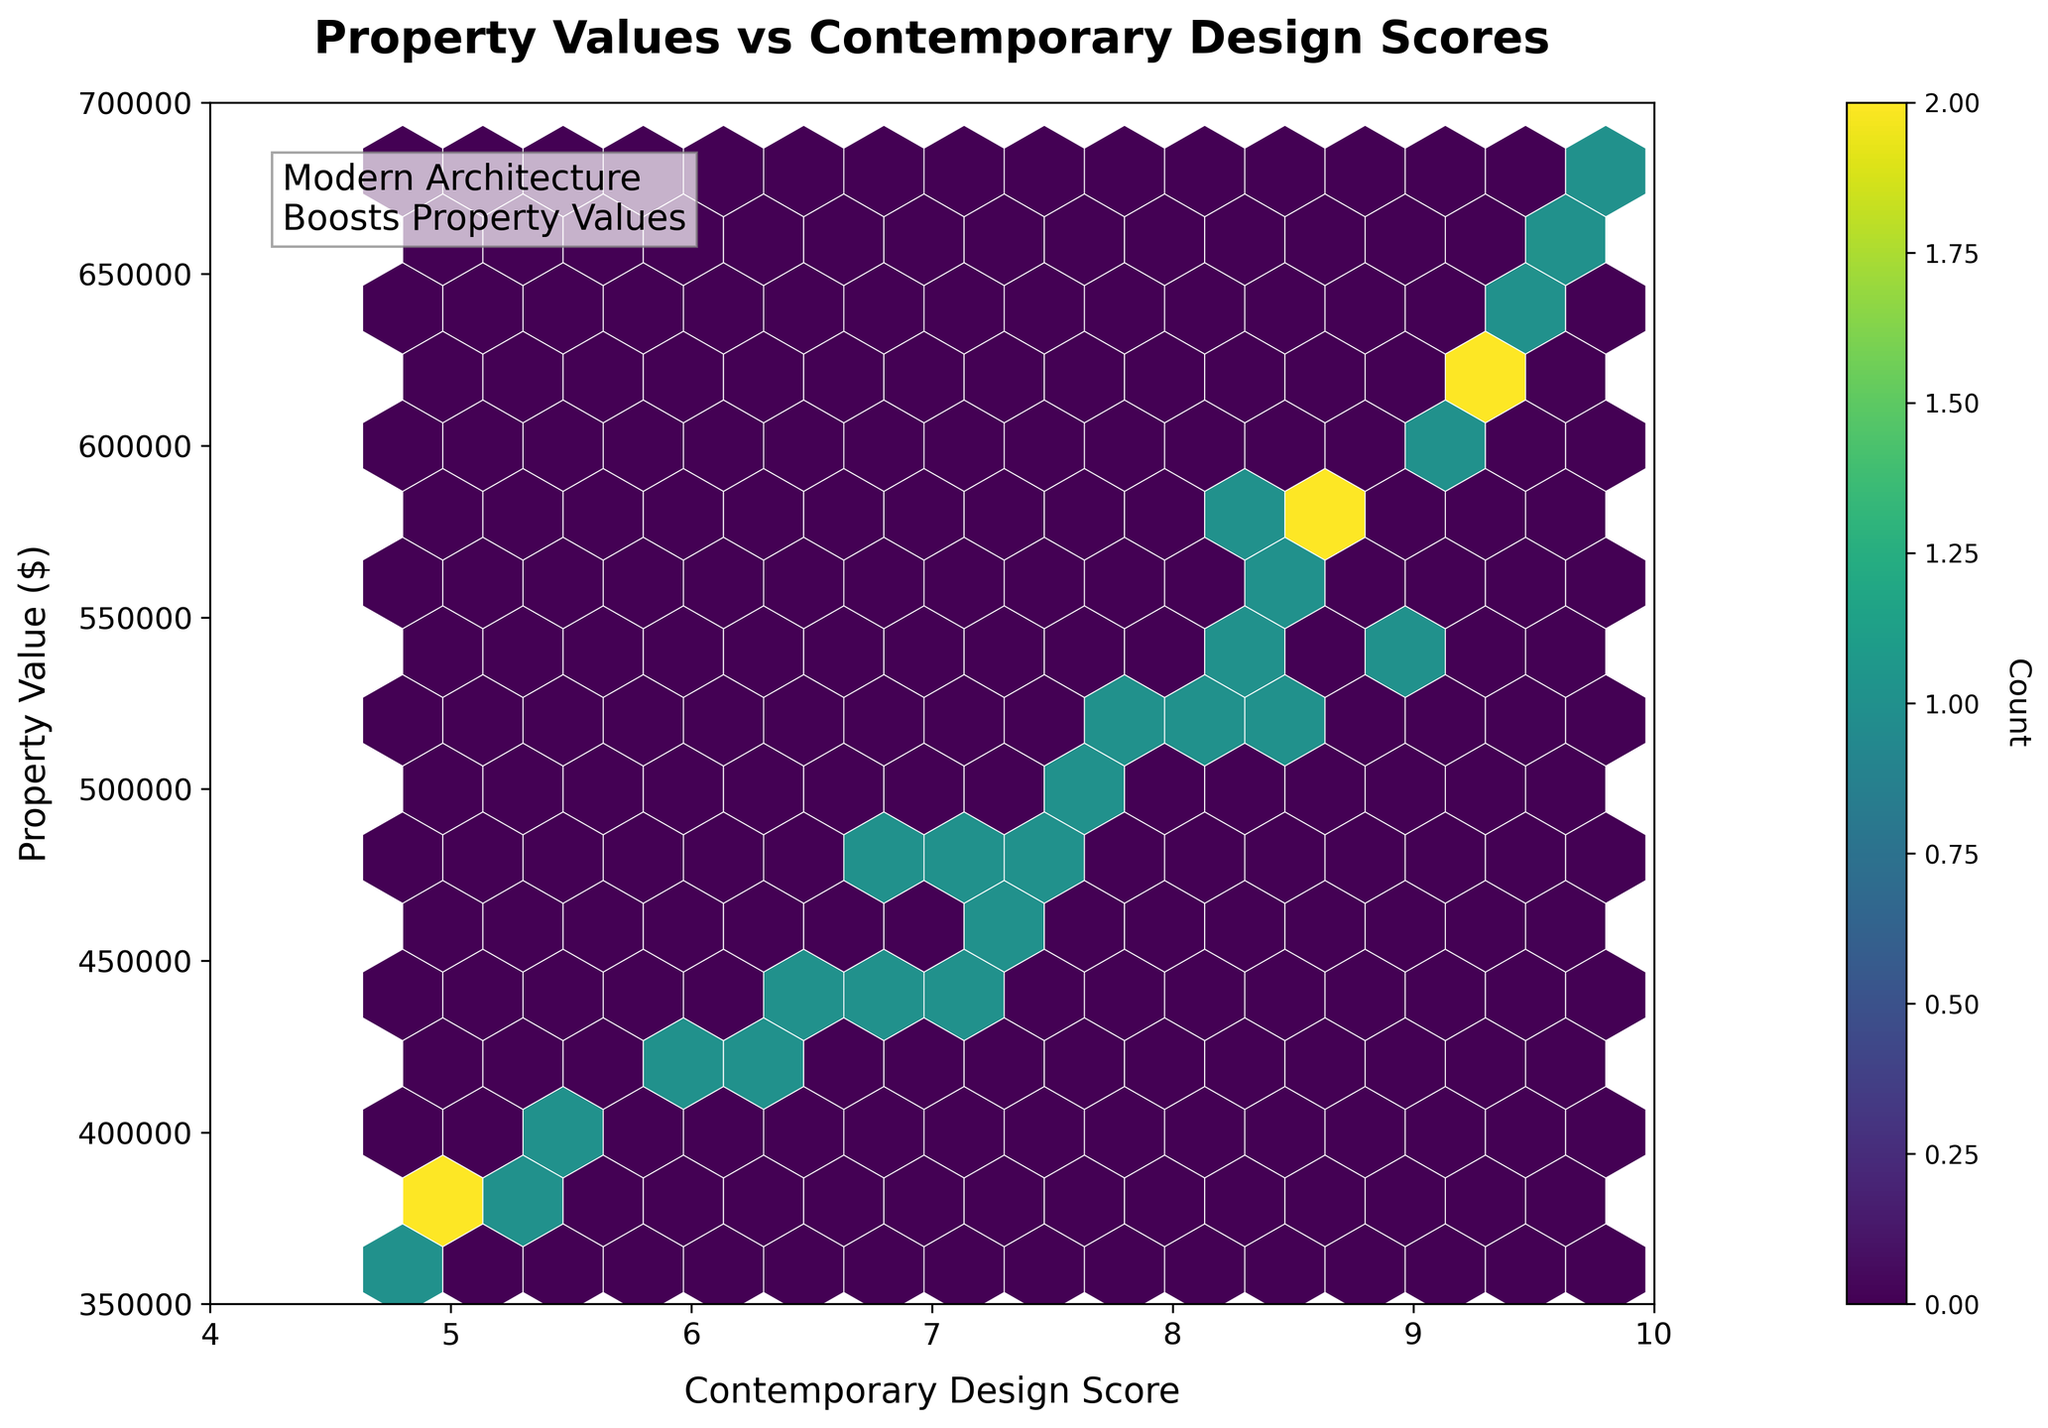What is the title of the Hexbin plot? The title is located at the top of the figure and it usually summarizes the main topic or relationship the plot is depicting. Here, the title at the top center of the plot reads "Property Values vs Contemporary Design Scores".
Answer: Property Values vs Contemporary Design Scores What does the color bar represent in the plot? The color bar, usually situated to the side of the plot, represents the count of data points falling within each hexbin. In this plot, the color bar shows how many data points are represented by each hexbin's color, with darker colors indicating higher counts.
Answer: Count of data points What are the labels of the x-axis and y-axis? The x-axis label is found along the horizontal axis, and the y-axis label is along the vertical axis. In this plot, the x-axis is labeled "Contemporary Design Score" and the y-axis is labeled "Property Value ($)."
Answer: Contemporary Design Score; Property Value ($) What range of Contemporary Design Scores does the plot display? The x-axis range specifies the values displayed on the horizontal axis. In this case, the plot spans Contemporary Design Scores from 4 to 10, as indicated by the x-axis limits.
Answer: 4 to 10 What does the text box in the plot indicate? The text box generally highlights a key insight or observation about the data. Here, the text box in the plot reads "Modern Architecture\nBoosts Property Values," suggesting that higher Contemporary Design Scores are associated with higher Property Values.
Answer: Modern Architecture Boosts Property Values At what Contemporary Design Score do we observe the highest concentration of high property values? By examining the color intensity within the hexbin grid, we can observe where the property values are highest. The highest concentration of high property values appears around a Contemporary Design Score of 9 to 10, as indicated by the densest, darkest hexagons.
Answer: 9 to 10 What is the relationship between Contemporary Design Scores and Property Values as illustrated by the plot? The relationship can be inferred from the general trend shown by the hexbin distribution. Here, there is a positive correlation: as Contemporary Design Scores increase, Property Values tend to be higher, indicated by denser high-value hexagons towards the right of the plot.
Answer: Positive correlation Compare the property values for areas with Contemporary Design Scores of 5 and 9. Which areas look more prosperous based on property values and how do you determine this? To compare prosperity based on property values, we look at the vertical distribution of points for each score. Areas with a score of 9 show higher property values, with denser hexagons indicating more frequent high-value properties around $600,000 to $680,000, while scores of 5 have lower values around $350,000 to $450,000.
Answer: Scores of 9 are more prosperous What is the primary insight the plot aims to communicate using the relationship between Contemporary Design Scores and Property Values? The primary insight is conveyed through the plot title, hexbin distribution, color intensity and additional text box. Here, it illustrates that neighborhoods with higher Contemporary Design Scores tend to have higher Property Values, suggesting a benefit of modern architectural styles on property economy.
Answer: Higher design scores boost property values 